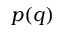<formula> <loc_0><loc_0><loc_500><loc_500>p ( q )</formula> 